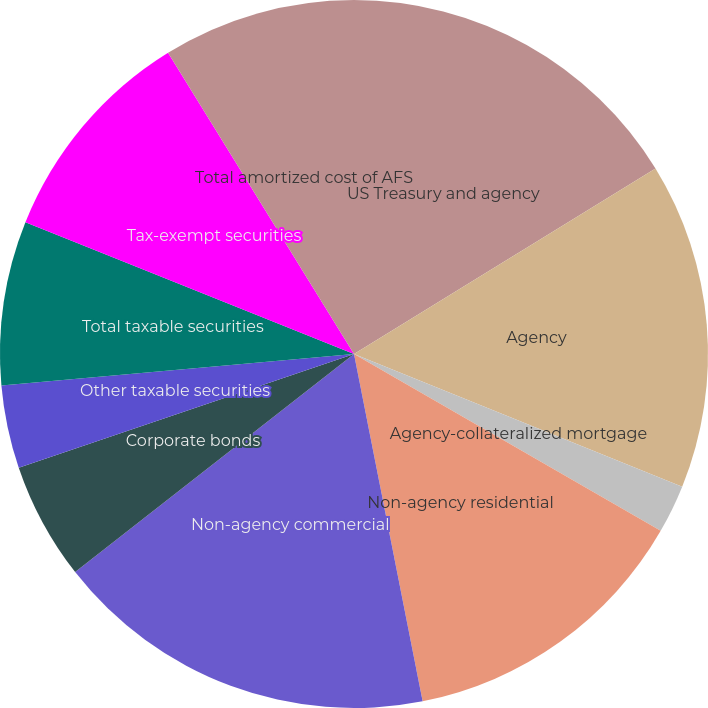Convert chart. <chart><loc_0><loc_0><loc_500><loc_500><pie_chart><fcel>US Treasury and agency<fcel>Agency<fcel>Agency-collateralized mortgage<fcel>Non-agency residential<fcel>Non-agency commercial<fcel>Corporate bonds<fcel>Other taxable securities<fcel>Total taxable securities<fcel>Tax-exempt securities<fcel>Total amortized cost of AFS<nl><fcel>16.22%<fcel>14.89%<fcel>2.21%<fcel>13.57%<fcel>17.54%<fcel>5.36%<fcel>3.79%<fcel>7.48%<fcel>10.13%<fcel>8.8%<nl></chart> 